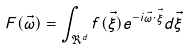<formula> <loc_0><loc_0><loc_500><loc_500>F ( \vec { \omega } ) = \int _ { \Re ^ { d } } f ( \vec { \xi } ) e ^ { - i \vec { \omega } \cdot \vec { \xi } } d \vec { \xi }</formula> 